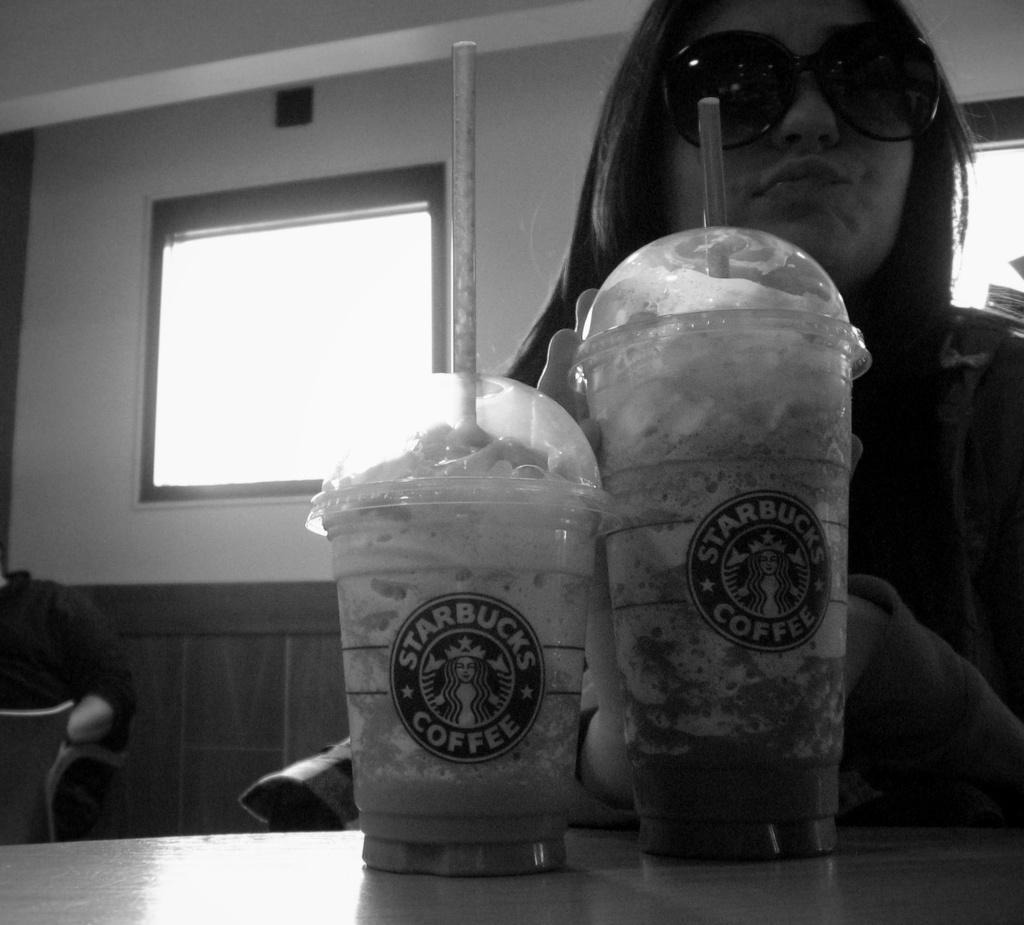Describe this image in one or two sentences. This image is taken inside a room. In the left side of the image there is a person sitting on a chair. In the right side of the image there is a woman sitting on a chair holding a coffee mug in her hand with a straw in it. There is a table in this image. There is a wall with a window. 